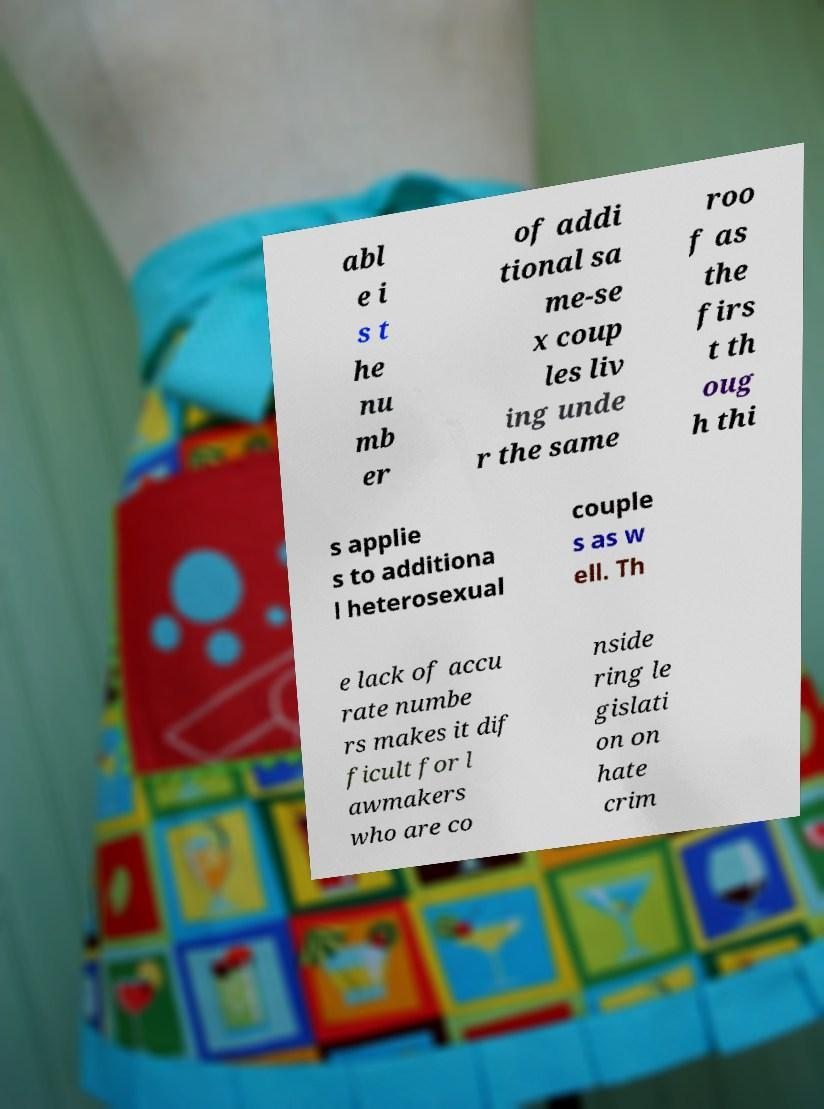Please identify and transcribe the text found in this image. abl e i s t he nu mb er of addi tional sa me-se x coup les liv ing unde r the same roo f as the firs t th oug h thi s applie s to additiona l heterosexual couple s as w ell. Th e lack of accu rate numbe rs makes it dif ficult for l awmakers who are co nside ring le gislati on on hate crim 